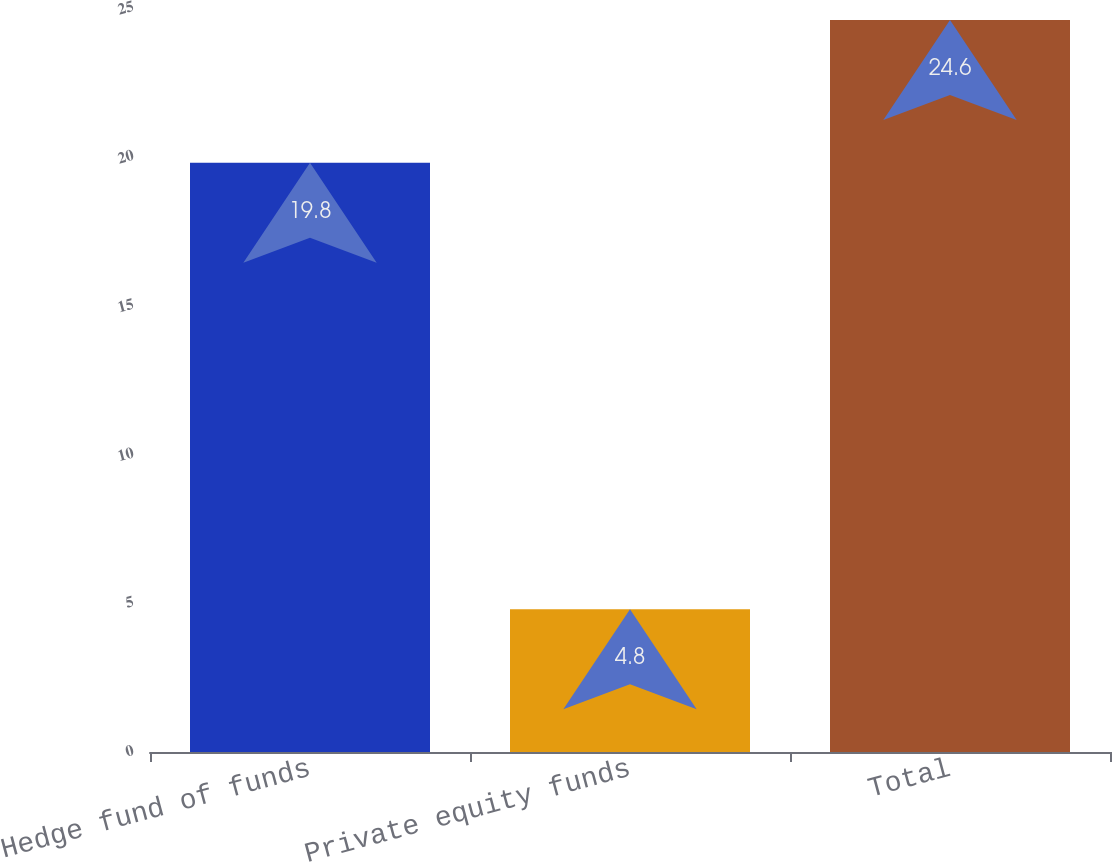Convert chart to OTSL. <chart><loc_0><loc_0><loc_500><loc_500><bar_chart><fcel>Hedge fund of funds<fcel>Private equity funds<fcel>Total<nl><fcel>19.8<fcel>4.8<fcel>24.6<nl></chart> 